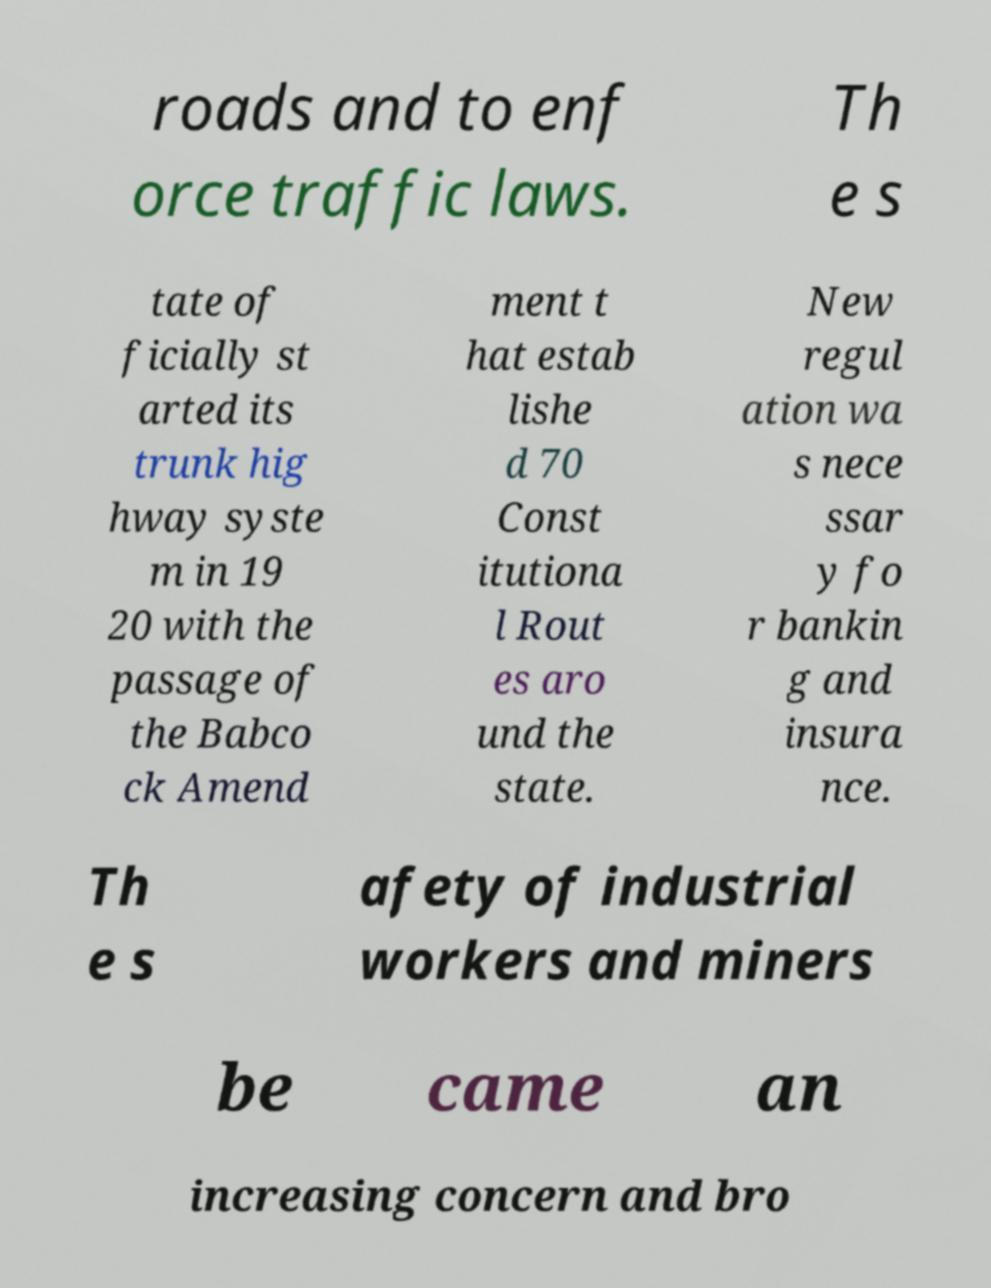Can you accurately transcribe the text from the provided image for me? roads and to enf orce traffic laws. Th e s tate of ficially st arted its trunk hig hway syste m in 19 20 with the passage of the Babco ck Amend ment t hat estab lishe d 70 Const itutiona l Rout es aro und the state. New regul ation wa s nece ssar y fo r bankin g and insura nce. Th e s afety of industrial workers and miners be came an increasing concern and bro 